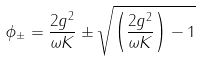Convert formula to latex. <formula><loc_0><loc_0><loc_500><loc_500>\phi _ { \pm } = \frac { 2 g ^ { 2 } } { \omega K } \pm \sqrt { \left ( \frac { 2 g ^ { 2 } } { \omega K } \right ) - 1 }</formula> 